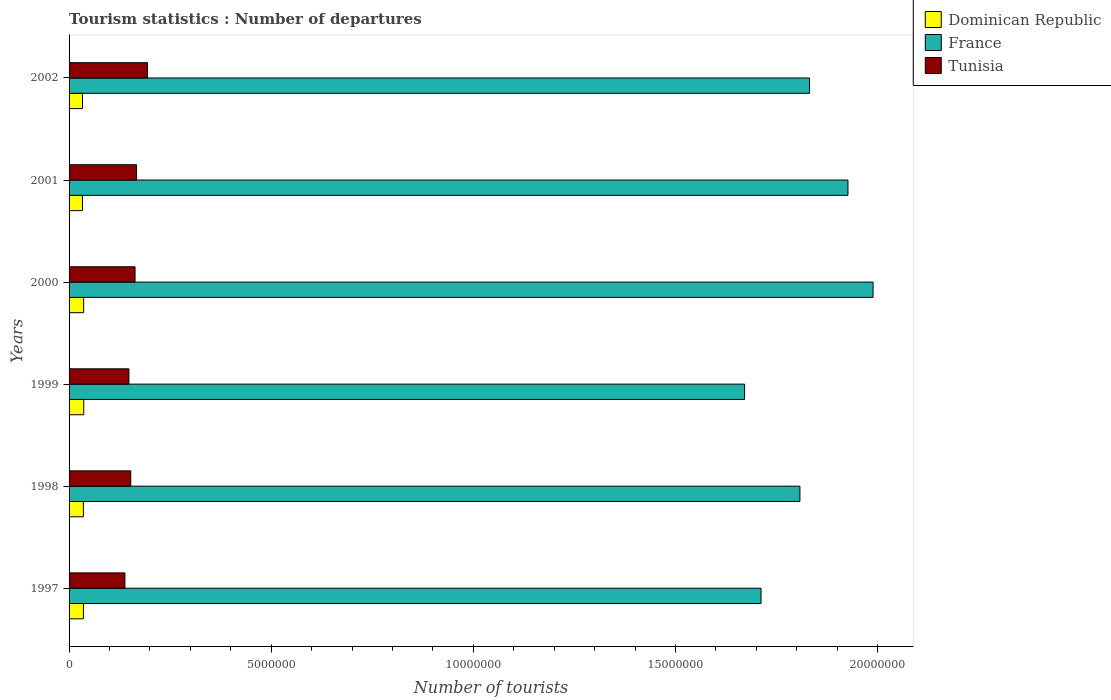Are the number of bars per tick equal to the number of legend labels?
Ensure brevity in your answer.  Yes. Are the number of bars on each tick of the Y-axis equal?
Ensure brevity in your answer.  Yes. How many bars are there on the 4th tick from the bottom?
Your answer should be very brief. 3. What is the label of the 5th group of bars from the top?
Your response must be concise. 1998. What is the number of tourist departures in Tunisia in 1997?
Give a very brief answer. 1.38e+06. Across all years, what is the maximum number of tourist departures in France?
Keep it short and to the point. 1.99e+07. Across all years, what is the minimum number of tourist departures in France?
Provide a short and direct response. 1.67e+07. In which year was the number of tourist departures in Dominican Republic maximum?
Ensure brevity in your answer.  1999. In which year was the number of tourist departures in Dominican Republic minimum?
Make the answer very short. 2001. What is the total number of tourist departures in Dominican Republic in the graph?
Make the answer very short. 2.10e+06. What is the difference between the number of tourist departures in Dominican Republic in 1997 and that in 2001?
Your response must be concise. 2.40e+04. What is the difference between the number of tourist departures in France in 1998 and the number of tourist departures in Tunisia in 2002?
Make the answer very short. 1.61e+07. What is the average number of tourist departures in France per year?
Keep it short and to the point. 1.82e+07. In the year 2002, what is the difference between the number of tourist departures in France and number of tourist departures in Tunisia?
Your answer should be very brief. 1.64e+07. What is the ratio of the number of tourist departures in Dominican Republic in 1999 to that in 2001?
Give a very brief answer. 1.1. Is the number of tourist departures in Tunisia in 1997 less than that in 1999?
Ensure brevity in your answer.  Yes. What is the difference between the highest and the second highest number of tourist departures in France?
Offer a very short reply. 6.21e+05. What is the difference between the highest and the lowest number of tourist departures in France?
Provide a succinct answer. 3.18e+06. In how many years, is the number of tourist departures in Dominican Republic greater than the average number of tourist departures in Dominican Republic taken over all years?
Provide a succinct answer. 4. Is the sum of the number of tourist departures in France in 1997 and 1998 greater than the maximum number of tourist departures in Tunisia across all years?
Make the answer very short. Yes. What does the 1st bar from the bottom in 2001 represents?
Your response must be concise. Dominican Republic. Are all the bars in the graph horizontal?
Your answer should be compact. Yes. What is the difference between two consecutive major ticks on the X-axis?
Provide a succinct answer. 5.00e+06. Are the values on the major ticks of X-axis written in scientific E-notation?
Provide a short and direct response. No. How are the legend labels stacked?
Keep it short and to the point. Vertical. What is the title of the graph?
Provide a short and direct response. Tourism statistics : Number of departures. What is the label or title of the X-axis?
Your response must be concise. Number of tourists. What is the label or title of the Y-axis?
Your answer should be very brief. Years. What is the Number of tourists of Dominican Republic in 1997?
Provide a succinct answer. 3.55e+05. What is the Number of tourists of France in 1997?
Keep it short and to the point. 1.71e+07. What is the Number of tourists in Tunisia in 1997?
Your response must be concise. 1.38e+06. What is the Number of tourists in Dominican Republic in 1998?
Ensure brevity in your answer.  3.54e+05. What is the Number of tourists in France in 1998?
Make the answer very short. 1.81e+07. What is the Number of tourists in Tunisia in 1998?
Your answer should be very brief. 1.53e+06. What is the Number of tourists in Dominican Republic in 1999?
Keep it short and to the point. 3.63e+05. What is the Number of tourists of France in 1999?
Your answer should be compact. 1.67e+07. What is the Number of tourists in Tunisia in 1999?
Your response must be concise. 1.48e+06. What is the Number of tourists of Dominican Republic in 2000?
Your answer should be very brief. 3.60e+05. What is the Number of tourists in France in 2000?
Your response must be concise. 1.99e+07. What is the Number of tourists of Tunisia in 2000?
Give a very brief answer. 1.63e+06. What is the Number of tourists in Dominican Republic in 2001?
Provide a short and direct response. 3.31e+05. What is the Number of tourists of France in 2001?
Keep it short and to the point. 1.93e+07. What is the Number of tourists of Tunisia in 2001?
Give a very brief answer. 1.67e+06. What is the Number of tourists in Dominican Republic in 2002?
Keep it short and to the point. 3.32e+05. What is the Number of tourists in France in 2002?
Your answer should be very brief. 1.83e+07. What is the Number of tourists in Tunisia in 2002?
Provide a succinct answer. 1.94e+06. Across all years, what is the maximum Number of tourists in Dominican Republic?
Keep it short and to the point. 3.63e+05. Across all years, what is the maximum Number of tourists of France?
Make the answer very short. 1.99e+07. Across all years, what is the maximum Number of tourists of Tunisia?
Make the answer very short. 1.94e+06. Across all years, what is the minimum Number of tourists of Dominican Republic?
Your response must be concise. 3.31e+05. Across all years, what is the minimum Number of tourists in France?
Make the answer very short. 1.67e+07. Across all years, what is the minimum Number of tourists of Tunisia?
Your response must be concise. 1.38e+06. What is the total Number of tourists in Dominican Republic in the graph?
Give a very brief answer. 2.10e+06. What is the total Number of tourists in France in the graph?
Keep it short and to the point. 1.09e+08. What is the total Number of tourists in Tunisia in the graph?
Offer a terse response. 9.63e+06. What is the difference between the Number of tourists of France in 1997 and that in 1998?
Ensure brevity in your answer.  -9.62e+05. What is the difference between the Number of tourists of Tunisia in 1997 and that in 1998?
Provide a short and direct response. -1.45e+05. What is the difference between the Number of tourists in Dominican Republic in 1997 and that in 1999?
Your response must be concise. -8000. What is the difference between the Number of tourists in France in 1997 and that in 1999?
Provide a short and direct response. 4.06e+05. What is the difference between the Number of tourists in Tunisia in 1997 and that in 1999?
Keep it short and to the point. -9.90e+04. What is the difference between the Number of tourists of Dominican Republic in 1997 and that in 2000?
Your answer should be very brief. -5000. What is the difference between the Number of tourists in France in 1997 and that in 2000?
Offer a terse response. -2.77e+06. What is the difference between the Number of tourists in Tunisia in 1997 and that in 2000?
Make the answer very short. -2.51e+05. What is the difference between the Number of tourists in Dominican Republic in 1997 and that in 2001?
Your answer should be very brief. 2.40e+04. What is the difference between the Number of tourists of France in 1997 and that in 2001?
Ensure brevity in your answer.  -2.15e+06. What is the difference between the Number of tourists in Tunisia in 1997 and that in 2001?
Keep it short and to the point. -2.88e+05. What is the difference between the Number of tourists of Dominican Republic in 1997 and that in 2002?
Give a very brief answer. 2.30e+04. What is the difference between the Number of tourists of France in 1997 and that in 2002?
Make the answer very short. -1.20e+06. What is the difference between the Number of tourists in Tunisia in 1997 and that in 2002?
Provide a succinct answer. -5.58e+05. What is the difference between the Number of tourists in Dominican Republic in 1998 and that in 1999?
Offer a terse response. -9000. What is the difference between the Number of tourists of France in 1998 and that in 1999?
Provide a succinct answer. 1.37e+06. What is the difference between the Number of tourists in Tunisia in 1998 and that in 1999?
Your answer should be very brief. 4.60e+04. What is the difference between the Number of tourists of Dominican Republic in 1998 and that in 2000?
Provide a succinct answer. -6000. What is the difference between the Number of tourists in France in 1998 and that in 2000?
Offer a terse response. -1.81e+06. What is the difference between the Number of tourists of Tunisia in 1998 and that in 2000?
Offer a terse response. -1.06e+05. What is the difference between the Number of tourists in Dominican Republic in 1998 and that in 2001?
Offer a terse response. 2.30e+04. What is the difference between the Number of tourists in France in 1998 and that in 2001?
Give a very brief answer. -1.19e+06. What is the difference between the Number of tourists of Tunisia in 1998 and that in 2001?
Give a very brief answer. -1.43e+05. What is the difference between the Number of tourists in Dominican Republic in 1998 and that in 2002?
Provide a succinct answer. 2.20e+04. What is the difference between the Number of tourists in France in 1998 and that in 2002?
Keep it short and to the point. -2.38e+05. What is the difference between the Number of tourists of Tunisia in 1998 and that in 2002?
Provide a succinct answer. -4.13e+05. What is the difference between the Number of tourists of Dominican Republic in 1999 and that in 2000?
Keep it short and to the point. 3000. What is the difference between the Number of tourists of France in 1999 and that in 2000?
Provide a short and direct response. -3.18e+06. What is the difference between the Number of tourists in Tunisia in 1999 and that in 2000?
Offer a terse response. -1.52e+05. What is the difference between the Number of tourists in Dominican Republic in 1999 and that in 2001?
Ensure brevity in your answer.  3.20e+04. What is the difference between the Number of tourists of France in 1999 and that in 2001?
Offer a very short reply. -2.56e+06. What is the difference between the Number of tourists of Tunisia in 1999 and that in 2001?
Offer a terse response. -1.89e+05. What is the difference between the Number of tourists in Dominican Republic in 1999 and that in 2002?
Offer a terse response. 3.10e+04. What is the difference between the Number of tourists of France in 1999 and that in 2002?
Provide a short and direct response. -1.61e+06. What is the difference between the Number of tourists in Tunisia in 1999 and that in 2002?
Offer a terse response. -4.59e+05. What is the difference between the Number of tourists in Dominican Republic in 2000 and that in 2001?
Give a very brief answer. 2.90e+04. What is the difference between the Number of tourists of France in 2000 and that in 2001?
Your response must be concise. 6.21e+05. What is the difference between the Number of tourists of Tunisia in 2000 and that in 2001?
Ensure brevity in your answer.  -3.70e+04. What is the difference between the Number of tourists in Dominican Republic in 2000 and that in 2002?
Your response must be concise. 2.80e+04. What is the difference between the Number of tourists in France in 2000 and that in 2002?
Your response must be concise. 1.57e+06. What is the difference between the Number of tourists in Tunisia in 2000 and that in 2002?
Provide a succinct answer. -3.07e+05. What is the difference between the Number of tourists of Dominican Republic in 2001 and that in 2002?
Ensure brevity in your answer.  -1000. What is the difference between the Number of tourists of France in 2001 and that in 2002?
Provide a succinct answer. 9.50e+05. What is the difference between the Number of tourists in Tunisia in 2001 and that in 2002?
Provide a short and direct response. -2.70e+05. What is the difference between the Number of tourists of Dominican Republic in 1997 and the Number of tourists of France in 1998?
Your answer should be compact. -1.77e+07. What is the difference between the Number of tourists in Dominican Republic in 1997 and the Number of tourists in Tunisia in 1998?
Offer a terse response. -1.17e+06. What is the difference between the Number of tourists of France in 1997 and the Number of tourists of Tunisia in 1998?
Your response must be concise. 1.56e+07. What is the difference between the Number of tourists of Dominican Republic in 1997 and the Number of tourists of France in 1999?
Offer a very short reply. -1.64e+07. What is the difference between the Number of tourists of Dominican Republic in 1997 and the Number of tourists of Tunisia in 1999?
Keep it short and to the point. -1.12e+06. What is the difference between the Number of tourists in France in 1997 and the Number of tourists in Tunisia in 1999?
Provide a succinct answer. 1.56e+07. What is the difference between the Number of tourists of Dominican Republic in 1997 and the Number of tourists of France in 2000?
Keep it short and to the point. -1.95e+07. What is the difference between the Number of tourists in Dominican Republic in 1997 and the Number of tourists in Tunisia in 2000?
Provide a short and direct response. -1.28e+06. What is the difference between the Number of tourists in France in 1997 and the Number of tourists in Tunisia in 2000?
Give a very brief answer. 1.55e+07. What is the difference between the Number of tourists of Dominican Republic in 1997 and the Number of tourists of France in 2001?
Offer a very short reply. -1.89e+07. What is the difference between the Number of tourists of Dominican Republic in 1997 and the Number of tourists of Tunisia in 2001?
Offer a very short reply. -1.31e+06. What is the difference between the Number of tourists in France in 1997 and the Number of tourists in Tunisia in 2001?
Provide a short and direct response. 1.54e+07. What is the difference between the Number of tourists in Dominican Republic in 1997 and the Number of tourists in France in 2002?
Keep it short and to the point. -1.80e+07. What is the difference between the Number of tourists of Dominican Republic in 1997 and the Number of tourists of Tunisia in 2002?
Ensure brevity in your answer.  -1.58e+06. What is the difference between the Number of tourists of France in 1997 and the Number of tourists of Tunisia in 2002?
Offer a very short reply. 1.52e+07. What is the difference between the Number of tourists of Dominican Republic in 1998 and the Number of tourists of France in 1999?
Keep it short and to the point. -1.64e+07. What is the difference between the Number of tourists of Dominican Republic in 1998 and the Number of tourists of Tunisia in 1999?
Your response must be concise. -1.13e+06. What is the difference between the Number of tourists of France in 1998 and the Number of tourists of Tunisia in 1999?
Offer a very short reply. 1.66e+07. What is the difference between the Number of tourists in Dominican Republic in 1998 and the Number of tourists in France in 2000?
Give a very brief answer. -1.95e+07. What is the difference between the Number of tourists of Dominican Republic in 1998 and the Number of tourists of Tunisia in 2000?
Give a very brief answer. -1.28e+06. What is the difference between the Number of tourists in France in 1998 and the Number of tourists in Tunisia in 2000?
Make the answer very short. 1.64e+07. What is the difference between the Number of tourists in Dominican Republic in 1998 and the Number of tourists in France in 2001?
Offer a terse response. -1.89e+07. What is the difference between the Number of tourists in Dominican Republic in 1998 and the Number of tourists in Tunisia in 2001?
Provide a succinct answer. -1.32e+06. What is the difference between the Number of tourists of France in 1998 and the Number of tourists of Tunisia in 2001?
Keep it short and to the point. 1.64e+07. What is the difference between the Number of tourists in Dominican Republic in 1998 and the Number of tourists in France in 2002?
Your answer should be very brief. -1.80e+07. What is the difference between the Number of tourists of Dominican Republic in 1998 and the Number of tourists of Tunisia in 2002?
Offer a terse response. -1.58e+06. What is the difference between the Number of tourists in France in 1998 and the Number of tourists in Tunisia in 2002?
Your answer should be compact. 1.61e+07. What is the difference between the Number of tourists in Dominican Republic in 1999 and the Number of tourists in France in 2000?
Make the answer very short. -1.95e+07. What is the difference between the Number of tourists in Dominican Republic in 1999 and the Number of tourists in Tunisia in 2000?
Offer a terse response. -1.27e+06. What is the difference between the Number of tourists of France in 1999 and the Number of tourists of Tunisia in 2000?
Provide a succinct answer. 1.51e+07. What is the difference between the Number of tourists of Dominican Republic in 1999 and the Number of tourists of France in 2001?
Your answer should be compact. -1.89e+07. What is the difference between the Number of tourists in Dominican Republic in 1999 and the Number of tourists in Tunisia in 2001?
Your answer should be compact. -1.31e+06. What is the difference between the Number of tourists of France in 1999 and the Number of tourists of Tunisia in 2001?
Your answer should be very brief. 1.50e+07. What is the difference between the Number of tourists of Dominican Republic in 1999 and the Number of tourists of France in 2002?
Your answer should be compact. -1.80e+07. What is the difference between the Number of tourists of Dominican Republic in 1999 and the Number of tourists of Tunisia in 2002?
Give a very brief answer. -1.58e+06. What is the difference between the Number of tourists in France in 1999 and the Number of tourists in Tunisia in 2002?
Offer a terse response. 1.48e+07. What is the difference between the Number of tourists in Dominican Republic in 2000 and the Number of tourists in France in 2001?
Your response must be concise. -1.89e+07. What is the difference between the Number of tourists of Dominican Republic in 2000 and the Number of tourists of Tunisia in 2001?
Offer a terse response. -1.31e+06. What is the difference between the Number of tourists of France in 2000 and the Number of tourists of Tunisia in 2001?
Provide a succinct answer. 1.82e+07. What is the difference between the Number of tourists of Dominican Republic in 2000 and the Number of tourists of France in 2002?
Your answer should be compact. -1.80e+07. What is the difference between the Number of tourists of Dominican Republic in 2000 and the Number of tourists of Tunisia in 2002?
Your response must be concise. -1.58e+06. What is the difference between the Number of tourists in France in 2000 and the Number of tourists in Tunisia in 2002?
Offer a terse response. 1.79e+07. What is the difference between the Number of tourists of Dominican Republic in 2001 and the Number of tourists of France in 2002?
Provide a short and direct response. -1.80e+07. What is the difference between the Number of tourists of Dominican Republic in 2001 and the Number of tourists of Tunisia in 2002?
Provide a succinct answer. -1.61e+06. What is the difference between the Number of tourists in France in 2001 and the Number of tourists in Tunisia in 2002?
Ensure brevity in your answer.  1.73e+07. What is the average Number of tourists in Dominican Republic per year?
Your answer should be compact. 3.49e+05. What is the average Number of tourists of France per year?
Provide a succinct answer. 1.82e+07. What is the average Number of tourists in Tunisia per year?
Keep it short and to the point. 1.60e+06. In the year 1997, what is the difference between the Number of tourists in Dominican Republic and Number of tourists in France?
Your answer should be compact. -1.68e+07. In the year 1997, what is the difference between the Number of tourists of Dominican Republic and Number of tourists of Tunisia?
Your answer should be very brief. -1.03e+06. In the year 1997, what is the difference between the Number of tourists in France and Number of tourists in Tunisia?
Keep it short and to the point. 1.57e+07. In the year 1998, what is the difference between the Number of tourists of Dominican Republic and Number of tourists of France?
Offer a very short reply. -1.77e+07. In the year 1998, what is the difference between the Number of tourists of Dominican Republic and Number of tourists of Tunisia?
Provide a short and direct response. -1.17e+06. In the year 1998, what is the difference between the Number of tourists in France and Number of tourists in Tunisia?
Your response must be concise. 1.66e+07. In the year 1999, what is the difference between the Number of tourists of Dominican Republic and Number of tourists of France?
Provide a short and direct response. -1.63e+07. In the year 1999, what is the difference between the Number of tourists of Dominican Republic and Number of tourists of Tunisia?
Make the answer very short. -1.12e+06. In the year 1999, what is the difference between the Number of tourists of France and Number of tourists of Tunisia?
Your response must be concise. 1.52e+07. In the year 2000, what is the difference between the Number of tourists of Dominican Republic and Number of tourists of France?
Your answer should be very brief. -1.95e+07. In the year 2000, what is the difference between the Number of tourists in Dominican Republic and Number of tourists in Tunisia?
Your answer should be very brief. -1.27e+06. In the year 2000, what is the difference between the Number of tourists of France and Number of tourists of Tunisia?
Your answer should be very brief. 1.83e+07. In the year 2001, what is the difference between the Number of tourists in Dominican Republic and Number of tourists in France?
Your response must be concise. -1.89e+07. In the year 2001, what is the difference between the Number of tourists in Dominican Republic and Number of tourists in Tunisia?
Ensure brevity in your answer.  -1.34e+06. In the year 2001, what is the difference between the Number of tourists of France and Number of tourists of Tunisia?
Your response must be concise. 1.76e+07. In the year 2002, what is the difference between the Number of tourists in Dominican Republic and Number of tourists in France?
Your answer should be very brief. -1.80e+07. In the year 2002, what is the difference between the Number of tourists of Dominican Republic and Number of tourists of Tunisia?
Your response must be concise. -1.61e+06. In the year 2002, what is the difference between the Number of tourists of France and Number of tourists of Tunisia?
Provide a short and direct response. 1.64e+07. What is the ratio of the Number of tourists of France in 1997 to that in 1998?
Provide a succinct answer. 0.95. What is the ratio of the Number of tourists in Tunisia in 1997 to that in 1998?
Keep it short and to the point. 0.91. What is the ratio of the Number of tourists of France in 1997 to that in 1999?
Ensure brevity in your answer.  1.02. What is the ratio of the Number of tourists of Tunisia in 1997 to that in 1999?
Your response must be concise. 0.93. What is the ratio of the Number of tourists in Dominican Republic in 1997 to that in 2000?
Your answer should be compact. 0.99. What is the ratio of the Number of tourists of France in 1997 to that in 2000?
Keep it short and to the point. 0.86. What is the ratio of the Number of tourists in Tunisia in 1997 to that in 2000?
Your response must be concise. 0.85. What is the ratio of the Number of tourists in Dominican Republic in 1997 to that in 2001?
Provide a short and direct response. 1.07. What is the ratio of the Number of tourists in France in 1997 to that in 2001?
Provide a short and direct response. 0.89. What is the ratio of the Number of tourists in Tunisia in 1997 to that in 2001?
Ensure brevity in your answer.  0.83. What is the ratio of the Number of tourists of Dominican Republic in 1997 to that in 2002?
Make the answer very short. 1.07. What is the ratio of the Number of tourists of France in 1997 to that in 2002?
Keep it short and to the point. 0.93. What is the ratio of the Number of tourists in Tunisia in 1997 to that in 2002?
Give a very brief answer. 0.71. What is the ratio of the Number of tourists of Dominican Republic in 1998 to that in 1999?
Ensure brevity in your answer.  0.98. What is the ratio of the Number of tourists in France in 1998 to that in 1999?
Keep it short and to the point. 1.08. What is the ratio of the Number of tourists of Tunisia in 1998 to that in 1999?
Offer a very short reply. 1.03. What is the ratio of the Number of tourists in Dominican Republic in 1998 to that in 2000?
Offer a very short reply. 0.98. What is the ratio of the Number of tourists of France in 1998 to that in 2000?
Your response must be concise. 0.91. What is the ratio of the Number of tourists in Tunisia in 1998 to that in 2000?
Make the answer very short. 0.94. What is the ratio of the Number of tourists of Dominican Republic in 1998 to that in 2001?
Your answer should be compact. 1.07. What is the ratio of the Number of tourists in France in 1998 to that in 2001?
Provide a short and direct response. 0.94. What is the ratio of the Number of tourists in Tunisia in 1998 to that in 2001?
Provide a succinct answer. 0.91. What is the ratio of the Number of tourists in Dominican Republic in 1998 to that in 2002?
Your answer should be very brief. 1.07. What is the ratio of the Number of tourists in France in 1998 to that in 2002?
Your answer should be compact. 0.99. What is the ratio of the Number of tourists of Tunisia in 1998 to that in 2002?
Make the answer very short. 0.79. What is the ratio of the Number of tourists in Dominican Republic in 1999 to that in 2000?
Ensure brevity in your answer.  1.01. What is the ratio of the Number of tourists in France in 1999 to that in 2000?
Give a very brief answer. 0.84. What is the ratio of the Number of tourists in Tunisia in 1999 to that in 2000?
Your answer should be compact. 0.91. What is the ratio of the Number of tourists of Dominican Republic in 1999 to that in 2001?
Provide a succinct answer. 1.1. What is the ratio of the Number of tourists in France in 1999 to that in 2001?
Give a very brief answer. 0.87. What is the ratio of the Number of tourists of Tunisia in 1999 to that in 2001?
Make the answer very short. 0.89. What is the ratio of the Number of tourists in Dominican Republic in 1999 to that in 2002?
Offer a terse response. 1.09. What is the ratio of the Number of tourists in France in 1999 to that in 2002?
Provide a succinct answer. 0.91. What is the ratio of the Number of tourists in Tunisia in 1999 to that in 2002?
Your answer should be very brief. 0.76. What is the ratio of the Number of tourists of Dominican Republic in 2000 to that in 2001?
Provide a succinct answer. 1.09. What is the ratio of the Number of tourists in France in 2000 to that in 2001?
Give a very brief answer. 1.03. What is the ratio of the Number of tourists in Tunisia in 2000 to that in 2001?
Make the answer very short. 0.98. What is the ratio of the Number of tourists in Dominican Republic in 2000 to that in 2002?
Offer a very short reply. 1.08. What is the ratio of the Number of tourists of France in 2000 to that in 2002?
Make the answer very short. 1.09. What is the ratio of the Number of tourists of Tunisia in 2000 to that in 2002?
Offer a terse response. 0.84. What is the ratio of the Number of tourists of Dominican Republic in 2001 to that in 2002?
Ensure brevity in your answer.  1. What is the ratio of the Number of tourists of France in 2001 to that in 2002?
Offer a terse response. 1.05. What is the ratio of the Number of tourists in Tunisia in 2001 to that in 2002?
Give a very brief answer. 0.86. What is the difference between the highest and the second highest Number of tourists in Dominican Republic?
Make the answer very short. 3000. What is the difference between the highest and the second highest Number of tourists in France?
Make the answer very short. 6.21e+05. What is the difference between the highest and the lowest Number of tourists in Dominican Republic?
Make the answer very short. 3.20e+04. What is the difference between the highest and the lowest Number of tourists in France?
Your answer should be compact. 3.18e+06. What is the difference between the highest and the lowest Number of tourists in Tunisia?
Provide a succinct answer. 5.58e+05. 